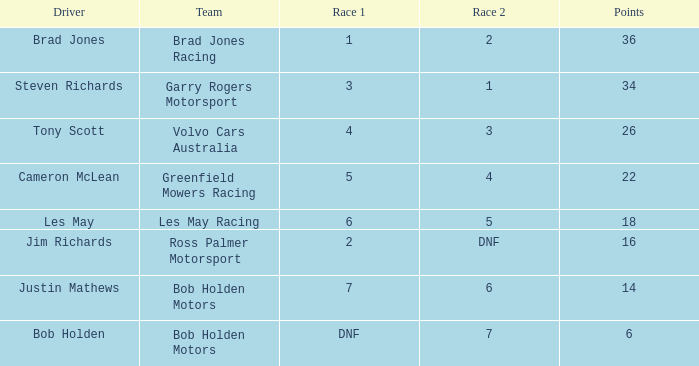Which driver for Bob Holden Motors has fewer than 36 points and placed 7 in race 1? Justin Mathews. 